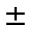Convert formula to latex. <formula><loc_0><loc_0><loc_500><loc_500>\pm</formula> 